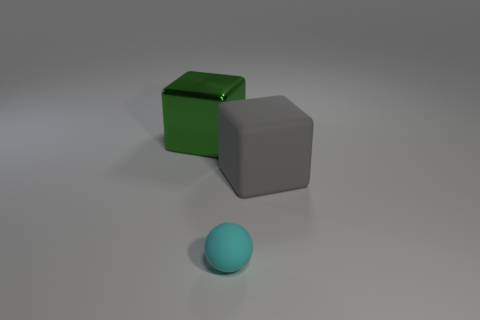Add 1 gray cubes. How many objects exist? 4 Subtract all cubes. How many objects are left? 1 Add 3 tiny cyan objects. How many tiny cyan objects exist? 4 Subtract 0 yellow cylinders. How many objects are left? 3 Subtract all green metallic objects. Subtract all big green things. How many objects are left? 1 Add 1 green shiny objects. How many green shiny objects are left? 2 